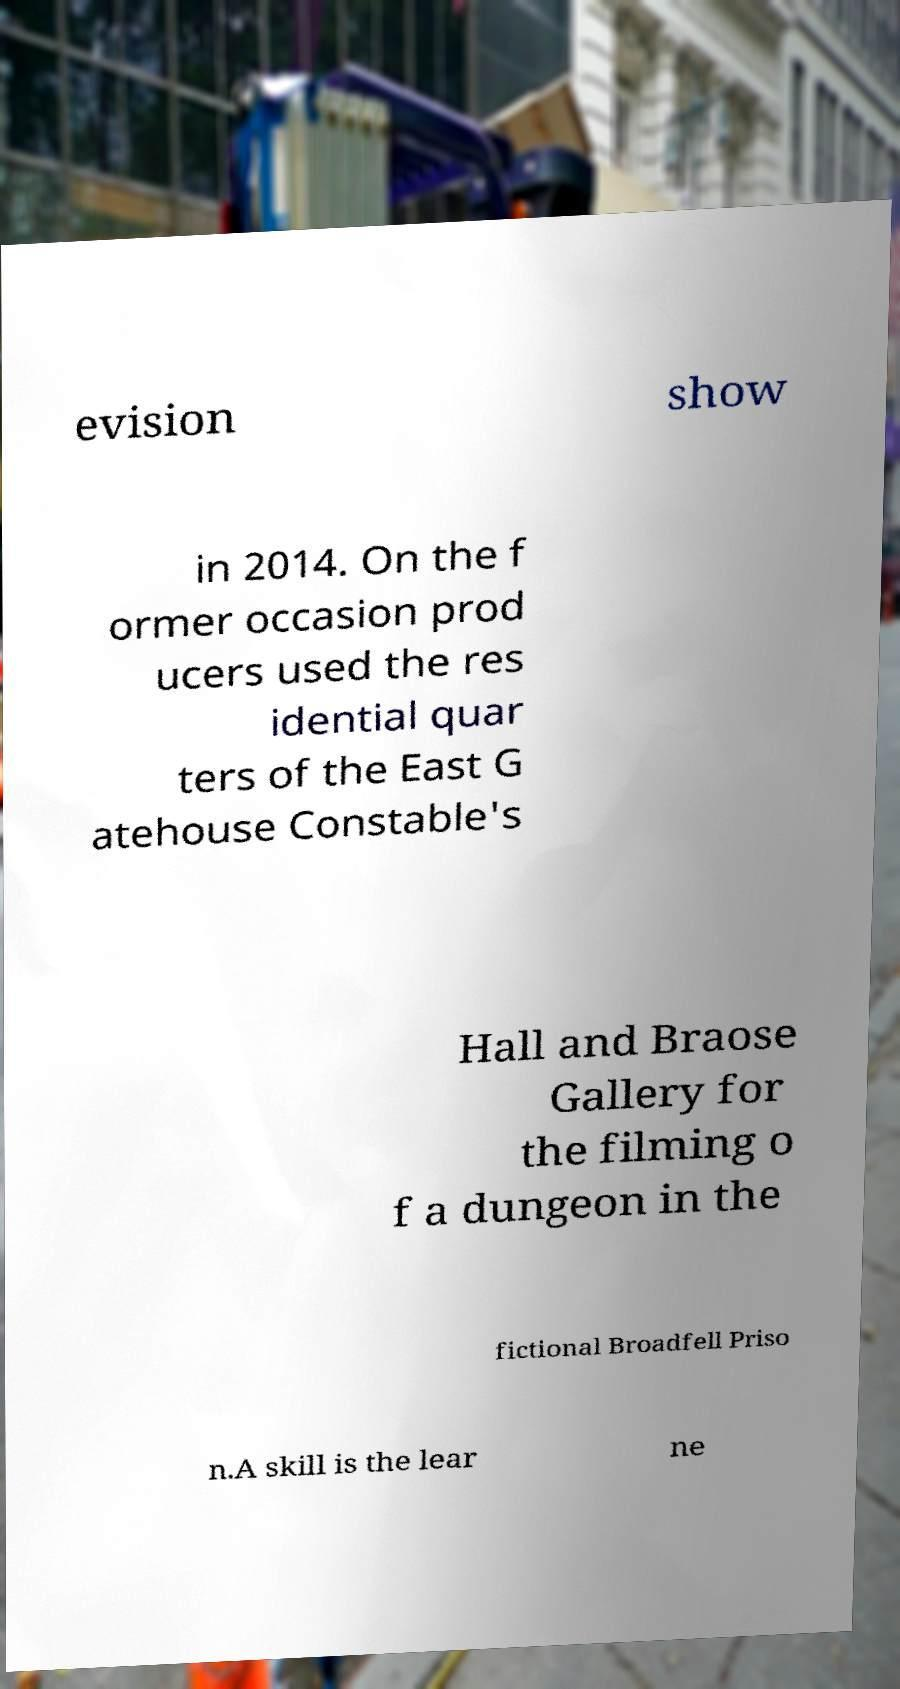For documentation purposes, I need the text within this image transcribed. Could you provide that? evision show in 2014. On the f ormer occasion prod ucers used the res idential quar ters of the East G atehouse Constable's Hall and Braose Gallery for the filming o f a dungeon in the fictional Broadfell Priso n.A skill is the lear ne 